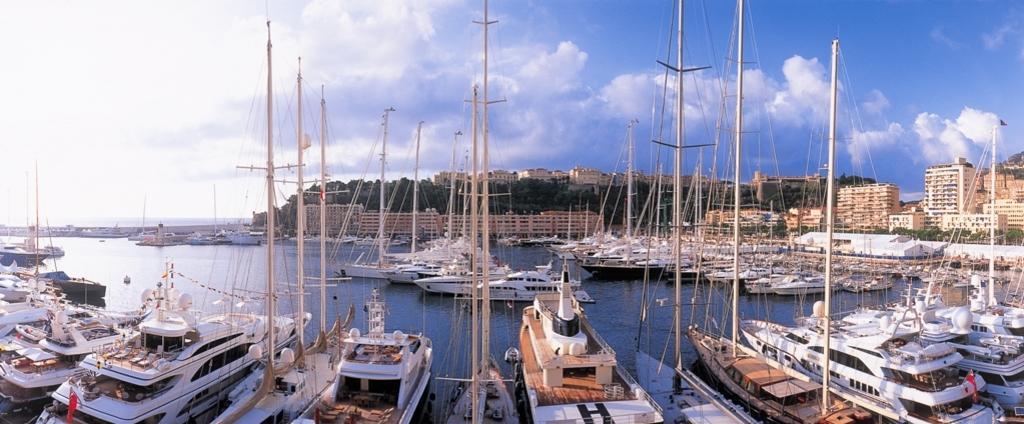Describe this image in one or two sentences. There are many boats with poles and ropes are on the water. In the background there are buildings, trees and sky with clouds. 